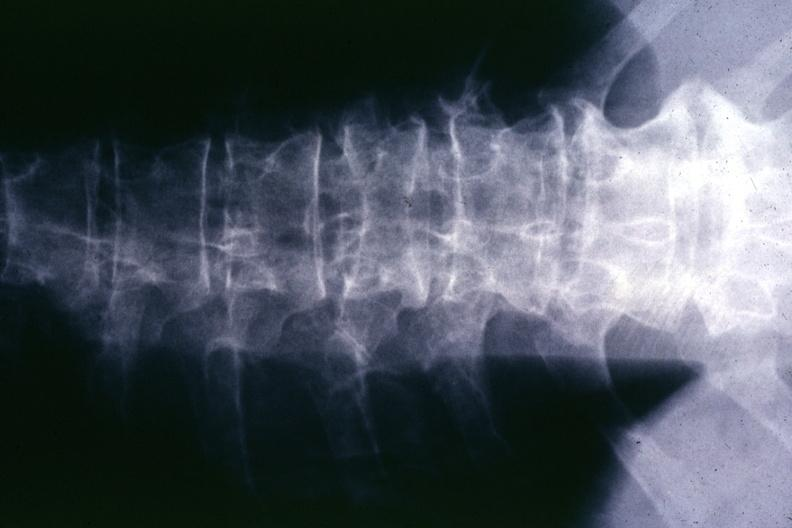s fixed tissue lateral view of vertebral bodies with many present?
Answer the question using a single word or phrase. No 